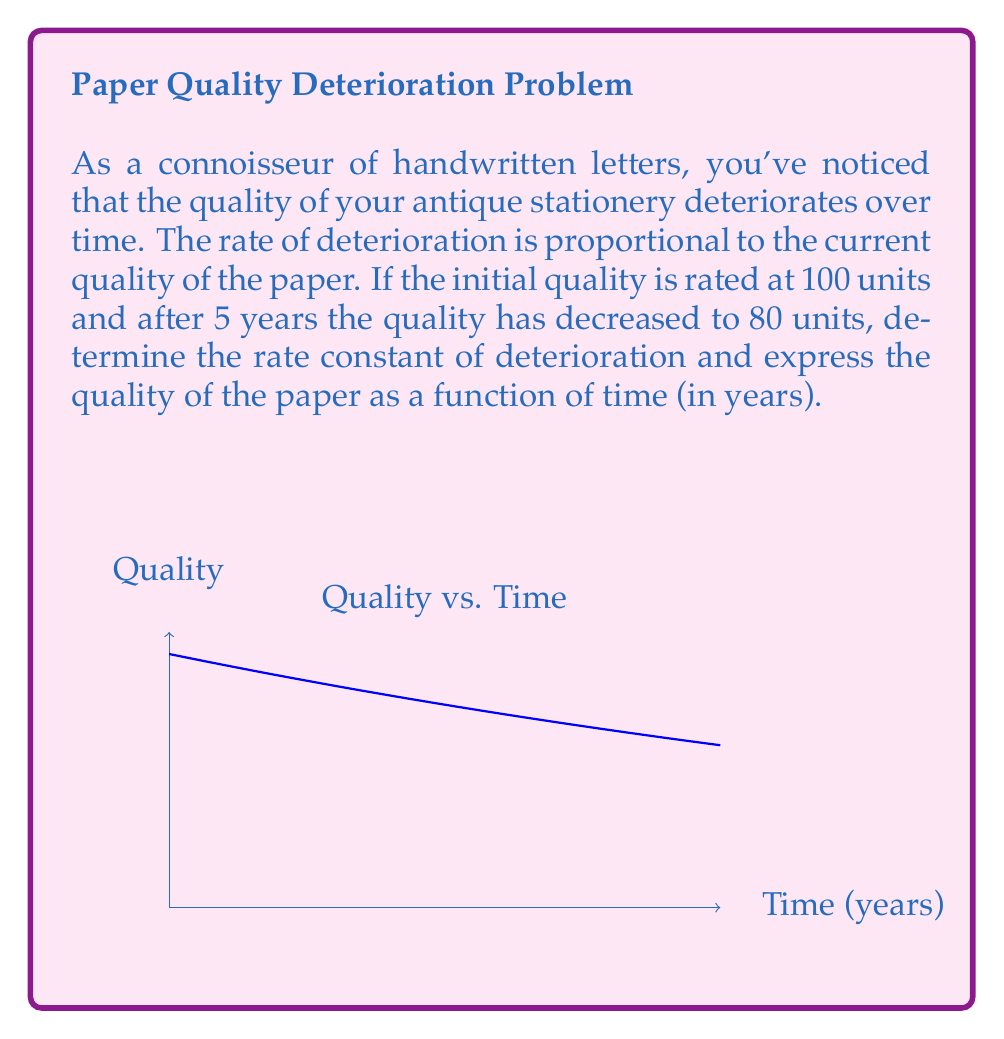Help me with this question. Let's approach this step-by-step:

1) Let $Q(t)$ be the quality of the paper at time $t$ (in years).

2) The rate of change of quality is proportional to the current quality:

   $$\frac{dQ}{dt} = -kQ$$

   where $k$ is the rate constant of deterioration.

3) This is a first-order separable differential equation. Solving it:

   $$\int \frac{dQ}{Q} = -k \int dt$$
   $$\ln|Q| = -kt + C$$
   $$Q(t) = Ae^{-kt}$$

   where $A$ is a constant.

4) Using the initial condition: $Q(0) = 100$, we find $A = 100$.

   $$Q(t) = 100e^{-kt}$$

5) Now, we use the condition that after 5 years, the quality is 80:

   $$80 = 100e^{-5k}$$

6) Solving for $k$:

   $$\frac{4}{5} = e^{-5k}$$
   $$\ln(\frac{4}{5}) = -5k$$
   $$k = -\frac{1}{5}\ln(\frac{4}{5}) \approx 0.0446$$

7) Therefore, the quality as a function of time is:

   $$Q(t) = 100e^{-0.0446t}$$
Answer: $Q(t) = 100e^{-0.0446t}$, where $t$ is in years. 